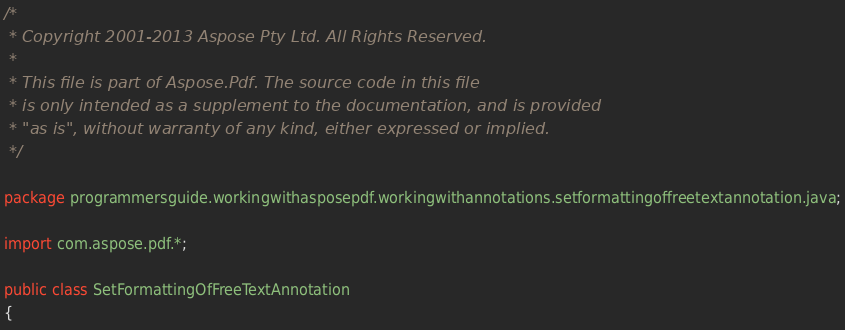Convert code to text. <code><loc_0><loc_0><loc_500><loc_500><_Java_>/* 
 * Copyright 2001-2013 Aspose Pty Ltd. All Rights Reserved.
 *
 * This file is part of Aspose.Pdf. The source code in this file
 * is only intended as a supplement to the documentation, and is provided
 * "as is", without warranty of any kind, either expressed or implied.
 */
 
package programmersguide.workingwithasposepdf.workingwithannotations.setformattingoffreetextannotation.java;

import com.aspose.pdf.*;

public class SetFormattingOfFreeTextAnnotation
{</code> 